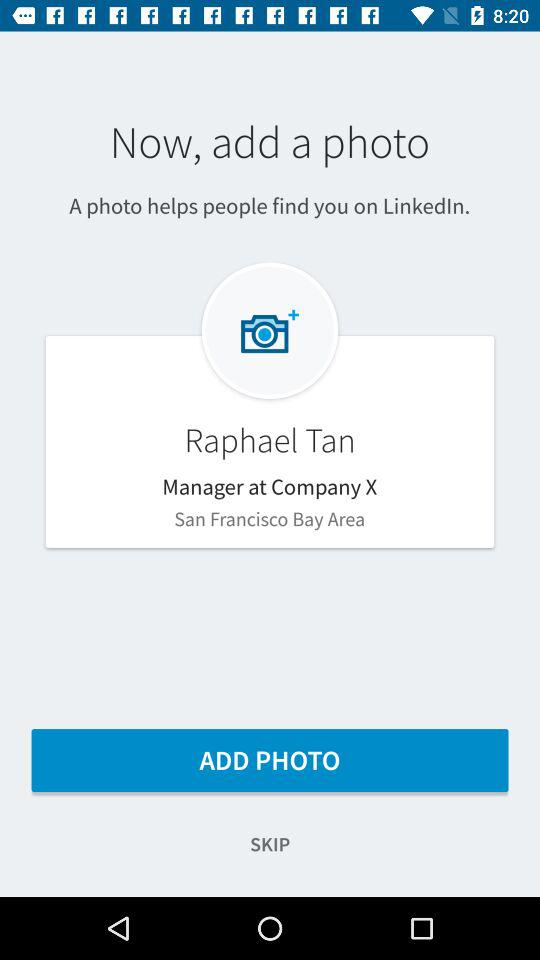Where is the company located? The company is located in the San Francisco Bay Area. 